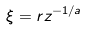Convert formula to latex. <formula><loc_0><loc_0><loc_500><loc_500>\xi = r z ^ { - 1 / a }</formula> 